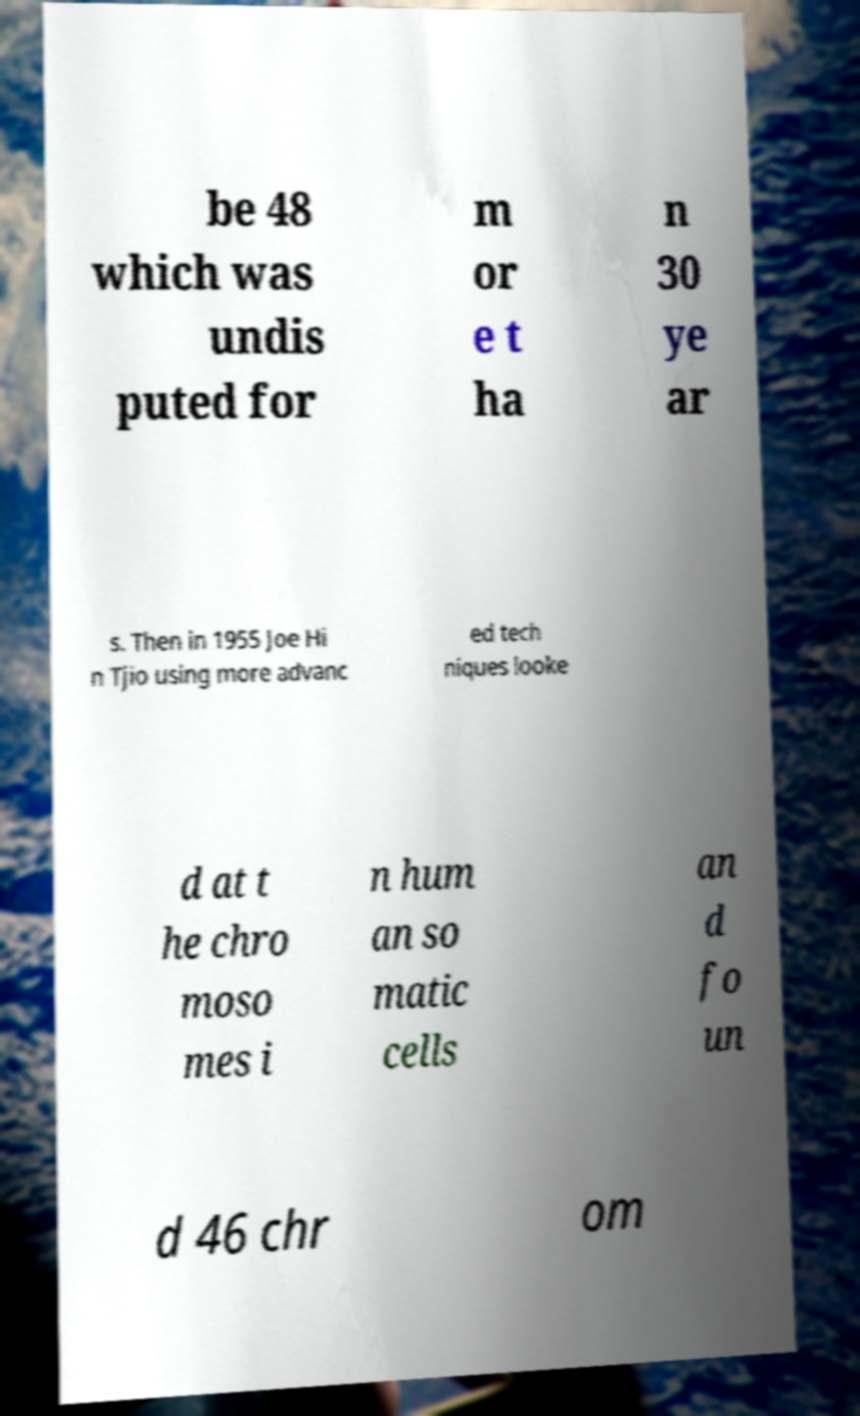What messages or text are displayed in this image? I need them in a readable, typed format. be 48 which was undis puted for m or e t ha n 30 ye ar s. Then in 1955 Joe Hi n Tjio using more advanc ed tech niques looke d at t he chro moso mes i n hum an so matic cells an d fo un d 46 chr om 